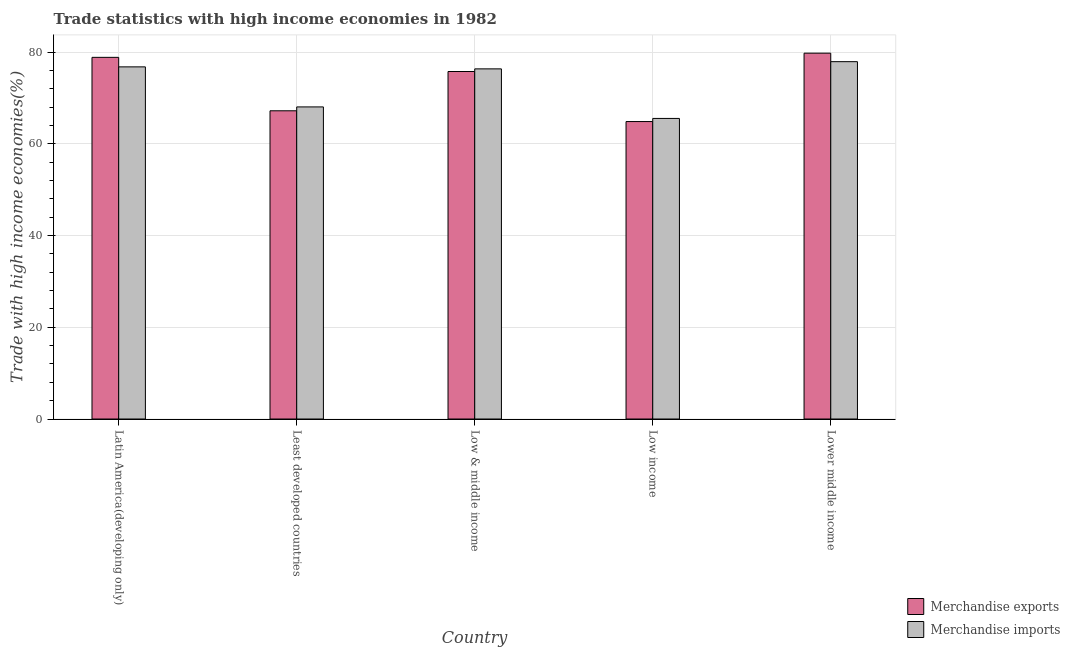How many different coloured bars are there?
Your answer should be compact. 2. How many groups of bars are there?
Provide a short and direct response. 5. Are the number of bars per tick equal to the number of legend labels?
Make the answer very short. Yes. Are the number of bars on each tick of the X-axis equal?
Offer a very short reply. Yes. How many bars are there on the 2nd tick from the left?
Your response must be concise. 2. What is the label of the 5th group of bars from the left?
Provide a succinct answer. Lower middle income. What is the merchandise exports in Low & middle income?
Give a very brief answer. 75.75. Across all countries, what is the maximum merchandise imports?
Your answer should be compact. 77.9. Across all countries, what is the minimum merchandise imports?
Your answer should be compact. 65.52. In which country was the merchandise exports maximum?
Give a very brief answer. Lower middle income. What is the total merchandise exports in the graph?
Provide a short and direct response. 366.38. What is the difference between the merchandise exports in Least developed countries and that in Low income?
Your answer should be compact. 2.35. What is the difference between the merchandise exports in Low income and the merchandise imports in Least developed countries?
Your answer should be compact. -3.19. What is the average merchandise imports per country?
Offer a terse response. 72.91. What is the difference between the merchandise exports and merchandise imports in Low & middle income?
Ensure brevity in your answer.  -0.57. What is the ratio of the merchandise imports in Latin America(developing only) to that in Low & middle income?
Make the answer very short. 1.01. Is the difference between the merchandise exports in Least developed countries and Low income greater than the difference between the merchandise imports in Least developed countries and Low income?
Your answer should be compact. No. What is the difference between the highest and the second highest merchandise exports?
Keep it short and to the point. 0.91. What is the difference between the highest and the lowest merchandise exports?
Provide a succinct answer. 14.91. In how many countries, is the merchandise exports greater than the average merchandise exports taken over all countries?
Offer a very short reply. 3. What does the 2nd bar from the right in Low income represents?
Provide a short and direct response. Merchandise exports. What is the difference between two consecutive major ticks on the Y-axis?
Give a very brief answer. 20. Does the graph contain grids?
Your answer should be compact. Yes. Where does the legend appear in the graph?
Offer a very short reply. Bottom right. How are the legend labels stacked?
Ensure brevity in your answer.  Vertical. What is the title of the graph?
Provide a short and direct response. Trade statistics with high income economies in 1982. Does "Money lenders" appear as one of the legend labels in the graph?
Keep it short and to the point. No. What is the label or title of the X-axis?
Keep it short and to the point. Country. What is the label or title of the Y-axis?
Offer a very short reply. Trade with high income economies(%). What is the Trade with high income economies(%) in Merchandise exports in Latin America(developing only)?
Give a very brief answer. 78.84. What is the Trade with high income economies(%) of Merchandise imports in Latin America(developing only)?
Your answer should be compact. 76.76. What is the Trade with high income economies(%) in Merchandise exports in Least developed countries?
Your answer should be compact. 67.19. What is the Trade with high income economies(%) in Merchandise imports in Least developed countries?
Your response must be concise. 68.03. What is the Trade with high income economies(%) of Merchandise exports in Low & middle income?
Your answer should be compact. 75.75. What is the Trade with high income economies(%) of Merchandise imports in Low & middle income?
Ensure brevity in your answer.  76.33. What is the Trade with high income economies(%) in Merchandise exports in Low income?
Give a very brief answer. 64.84. What is the Trade with high income economies(%) of Merchandise imports in Low income?
Make the answer very short. 65.52. What is the Trade with high income economies(%) in Merchandise exports in Lower middle income?
Your answer should be compact. 79.75. What is the Trade with high income economies(%) in Merchandise imports in Lower middle income?
Keep it short and to the point. 77.9. Across all countries, what is the maximum Trade with high income economies(%) in Merchandise exports?
Provide a short and direct response. 79.75. Across all countries, what is the maximum Trade with high income economies(%) of Merchandise imports?
Offer a terse response. 77.9. Across all countries, what is the minimum Trade with high income economies(%) in Merchandise exports?
Offer a very short reply. 64.84. Across all countries, what is the minimum Trade with high income economies(%) in Merchandise imports?
Make the answer very short. 65.52. What is the total Trade with high income economies(%) in Merchandise exports in the graph?
Your answer should be compact. 366.38. What is the total Trade with high income economies(%) in Merchandise imports in the graph?
Your response must be concise. 364.55. What is the difference between the Trade with high income economies(%) of Merchandise exports in Latin America(developing only) and that in Least developed countries?
Make the answer very short. 11.65. What is the difference between the Trade with high income economies(%) in Merchandise imports in Latin America(developing only) and that in Least developed countries?
Provide a succinct answer. 8.73. What is the difference between the Trade with high income economies(%) in Merchandise exports in Latin America(developing only) and that in Low & middle income?
Your answer should be very brief. 3.09. What is the difference between the Trade with high income economies(%) of Merchandise imports in Latin America(developing only) and that in Low & middle income?
Your response must be concise. 0.44. What is the difference between the Trade with high income economies(%) in Merchandise exports in Latin America(developing only) and that in Low income?
Provide a succinct answer. 14. What is the difference between the Trade with high income economies(%) of Merchandise imports in Latin America(developing only) and that in Low income?
Provide a succinct answer. 11.24. What is the difference between the Trade with high income economies(%) in Merchandise exports in Latin America(developing only) and that in Lower middle income?
Your answer should be very brief. -0.91. What is the difference between the Trade with high income economies(%) in Merchandise imports in Latin America(developing only) and that in Lower middle income?
Offer a very short reply. -1.14. What is the difference between the Trade with high income economies(%) of Merchandise exports in Least developed countries and that in Low & middle income?
Your answer should be compact. -8.56. What is the difference between the Trade with high income economies(%) in Merchandise imports in Least developed countries and that in Low & middle income?
Provide a short and direct response. -8.29. What is the difference between the Trade with high income economies(%) of Merchandise exports in Least developed countries and that in Low income?
Your answer should be very brief. 2.35. What is the difference between the Trade with high income economies(%) in Merchandise imports in Least developed countries and that in Low income?
Your response must be concise. 2.51. What is the difference between the Trade with high income economies(%) in Merchandise exports in Least developed countries and that in Lower middle income?
Make the answer very short. -12.56. What is the difference between the Trade with high income economies(%) in Merchandise imports in Least developed countries and that in Lower middle income?
Offer a very short reply. -9.87. What is the difference between the Trade with high income economies(%) of Merchandise exports in Low & middle income and that in Low income?
Make the answer very short. 10.91. What is the difference between the Trade with high income economies(%) of Merchandise imports in Low & middle income and that in Low income?
Your answer should be compact. 10.8. What is the difference between the Trade with high income economies(%) of Merchandise exports in Low & middle income and that in Lower middle income?
Keep it short and to the point. -4. What is the difference between the Trade with high income economies(%) in Merchandise imports in Low & middle income and that in Lower middle income?
Your response must be concise. -1.57. What is the difference between the Trade with high income economies(%) of Merchandise exports in Low income and that in Lower middle income?
Offer a very short reply. -14.91. What is the difference between the Trade with high income economies(%) of Merchandise imports in Low income and that in Lower middle income?
Provide a short and direct response. -12.38. What is the difference between the Trade with high income economies(%) in Merchandise exports in Latin America(developing only) and the Trade with high income economies(%) in Merchandise imports in Least developed countries?
Provide a short and direct response. 10.81. What is the difference between the Trade with high income economies(%) of Merchandise exports in Latin America(developing only) and the Trade with high income economies(%) of Merchandise imports in Low & middle income?
Give a very brief answer. 2.51. What is the difference between the Trade with high income economies(%) of Merchandise exports in Latin America(developing only) and the Trade with high income economies(%) of Merchandise imports in Low income?
Provide a short and direct response. 13.32. What is the difference between the Trade with high income economies(%) in Merchandise exports in Latin America(developing only) and the Trade with high income economies(%) in Merchandise imports in Lower middle income?
Offer a terse response. 0.94. What is the difference between the Trade with high income economies(%) in Merchandise exports in Least developed countries and the Trade with high income economies(%) in Merchandise imports in Low & middle income?
Your response must be concise. -9.14. What is the difference between the Trade with high income economies(%) of Merchandise exports in Least developed countries and the Trade with high income economies(%) of Merchandise imports in Low income?
Your response must be concise. 1.67. What is the difference between the Trade with high income economies(%) in Merchandise exports in Least developed countries and the Trade with high income economies(%) in Merchandise imports in Lower middle income?
Keep it short and to the point. -10.71. What is the difference between the Trade with high income economies(%) in Merchandise exports in Low & middle income and the Trade with high income economies(%) in Merchandise imports in Low income?
Provide a succinct answer. 10.23. What is the difference between the Trade with high income economies(%) of Merchandise exports in Low & middle income and the Trade with high income economies(%) of Merchandise imports in Lower middle income?
Provide a short and direct response. -2.15. What is the difference between the Trade with high income economies(%) in Merchandise exports in Low income and the Trade with high income economies(%) in Merchandise imports in Lower middle income?
Keep it short and to the point. -13.06. What is the average Trade with high income economies(%) of Merchandise exports per country?
Provide a succinct answer. 73.28. What is the average Trade with high income economies(%) of Merchandise imports per country?
Offer a very short reply. 72.91. What is the difference between the Trade with high income economies(%) of Merchandise exports and Trade with high income economies(%) of Merchandise imports in Latin America(developing only)?
Your response must be concise. 2.08. What is the difference between the Trade with high income economies(%) of Merchandise exports and Trade with high income economies(%) of Merchandise imports in Least developed countries?
Offer a terse response. -0.84. What is the difference between the Trade with high income economies(%) of Merchandise exports and Trade with high income economies(%) of Merchandise imports in Low & middle income?
Offer a terse response. -0.57. What is the difference between the Trade with high income economies(%) of Merchandise exports and Trade with high income economies(%) of Merchandise imports in Low income?
Your answer should be very brief. -0.68. What is the difference between the Trade with high income economies(%) in Merchandise exports and Trade with high income economies(%) in Merchandise imports in Lower middle income?
Offer a terse response. 1.85. What is the ratio of the Trade with high income economies(%) of Merchandise exports in Latin America(developing only) to that in Least developed countries?
Your response must be concise. 1.17. What is the ratio of the Trade with high income economies(%) in Merchandise imports in Latin America(developing only) to that in Least developed countries?
Keep it short and to the point. 1.13. What is the ratio of the Trade with high income economies(%) in Merchandise exports in Latin America(developing only) to that in Low & middle income?
Your response must be concise. 1.04. What is the ratio of the Trade with high income economies(%) in Merchandise imports in Latin America(developing only) to that in Low & middle income?
Give a very brief answer. 1.01. What is the ratio of the Trade with high income economies(%) in Merchandise exports in Latin America(developing only) to that in Low income?
Offer a terse response. 1.22. What is the ratio of the Trade with high income economies(%) in Merchandise imports in Latin America(developing only) to that in Low income?
Ensure brevity in your answer.  1.17. What is the ratio of the Trade with high income economies(%) in Merchandise imports in Latin America(developing only) to that in Lower middle income?
Your answer should be compact. 0.99. What is the ratio of the Trade with high income economies(%) in Merchandise exports in Least developed countries to that in Low & middle income?
Make the answer very short. 0.89. What is the ratio of the Trade with high income economies(%) of Merchandise imports in Least developed countries to that in Low & middle income?
Offer a very short reply. 0.89. What is the ratio of the Trade with high income economies(%) in Merchandise exports in Least developed countries to that in Low income?
Offer a terse response. 1.04. What is the ratio of the Trade with high income economies(%) in Merchandise imports in Least developed countries to that in Low income?
Offer a very short reply. 1.04. What is the ratio of the Trade with high income economies(%) in Merchandise exports in Least developed countries to that in Lower middle income?
Give a very brief answer. 0.84. What is the ratio of the Trade with high income economies(%) of Merchandise imports in Least developed countries to that in Lower middle income?
Give a very brief answer. 0.87. What is the ratio of the Trade with high income economies(%) in Merchandise exports in Low & middle income to that in Low income?
Give a very brief answer. 1.17. What is the ratio of the Trade with high income economies(%) of Merchandise imports in Low & middle income to that in Low income?
Offer a very short reply. 1.16. What is the ratio of the Trade with high income economies(%) of Merchandise exports in Low & middle income to that in Lower middle income?
Offer a very short reply. 0.95. What is the ratio of the Trade with high income economies(%) of Merchandise imports in Low & middle income to that in Lower middle income?
Provide a short and direct response. 0.98. What is the ratio of the Trade with high income economies(%) in Merchandise exports in Low income to that in Lower middle income?
Your answer should be very brief. 0.81. What is the ratio of the Trade with high income economies(%) of Merchandise imports in Low income to that in Lower middle income?
Make the answer very short. 0.84. What is the difference between the highest and the second highest Trade with high income economies(%) in Merchandise exports?
Provide a short and direct response. 0.91. What is the difference between the highest and the second highest Trade with high income economies(%) in Merchandise imports?
Make the answer very short. 1.14. What is the difference between the highest and the lowest Trade with high income economies(%) of Merchandise exports?
Provide a succinct answer. 14.91. What is the difference between the highest and the lowest Trade with high income economies(%) in Merchandise imports?
Your answer should be compact. 12.38. 